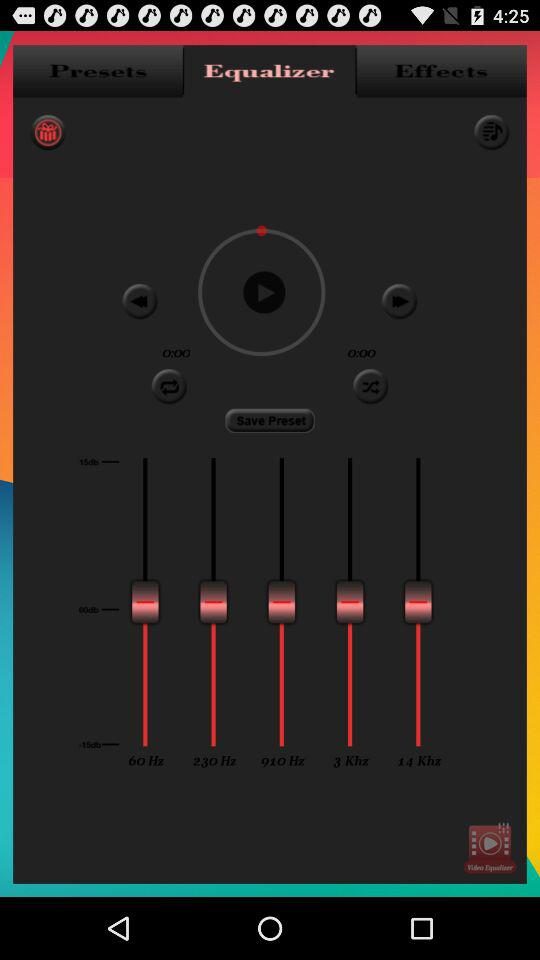Which tab is selected? The selected tab is "Equalizer". 